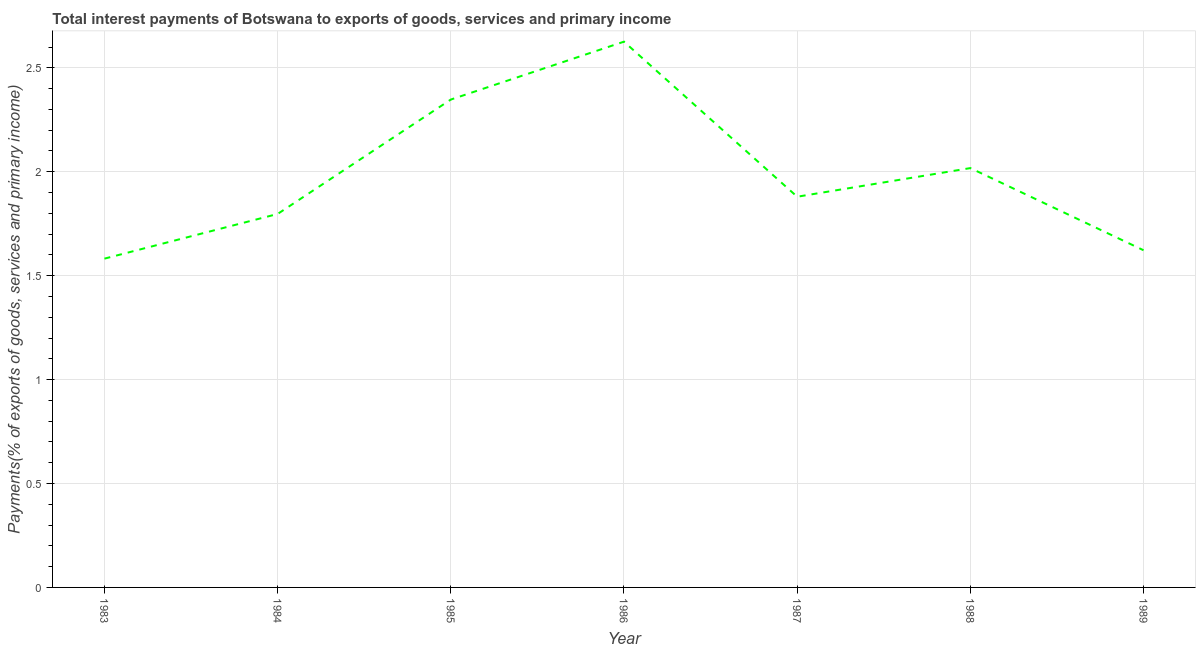What is the total interest payments on external debt in 1985?
Ensure brevity in your answer.  2.35. Across all years, what is the maximum total interest payments on external debt?
Your response must be concise. 2.63. Across all years, what is the minimum total interest payments on external debt?
Provide a short and direct response. 1.58. In which year was the total interest payments on external debt maximum?
Provide a short and direct response. 1986. In which year was the total interest payments on external debt minimum?
Give a very brief answer. 1983. What is the sum of the total interest payments on external debt?
Provide a short and direct response. 13.87. What is the difference between the total interest payments on external debt in 1985 and 1989?
Give a very brief answer. 0.73. What is the average total interest payments on external debt per year?
Offer a very short reply. 1.98. What is the median total interest payments on external debt?
Keep it short and to the point. 1.88. In how many years, is the total interest payments on external debt greater than 2 %?
Your answer should be compact. 3. What is the ratio of the total interest payments on external debt in 1987 to that in 1988?
Give a very brief answer. 0.93. What is the difference between the highest and the second highest total interest payments on external debt?
Keep it short and to the point. 0.28. Is the sum of the total interest payments on external debt in 1986 and 1988 greater than the maximum total interest payments on external debt across all years?
Offer a terse response. Yes. What is the difference between the highest and the lowest total interest payments on external debt?
Ensure brevity in your answer.  1.04. Does the total interest payments on external debt monotonically increase over the years?
Your response must be concise. No. How many lines are there?
Your answer should be very brief. 1. How many years are there in the graph?
Make the answer very short. 7. What is the difference between two consecutive major ticks on the Y-axis?
Your answer should be compact. 0.5. Does the graph contain any zero values?
Give a very brief answer. No. Does the graph contain grids?
Offer a terse response. Yes. What is the title of the graph?
Offer a terse response. Total interest payments of Botswana to exports of goods, services and primary income. What is the label or title of the X-axis?
Provide a succinct answer. Year. What is the label or title of the Y-axis?
Your answer should be compact. Payments(% of exports of goods, services and primary income). What is the Payments(% of exports of goods, services and primary income) in 1983?
Your answer should be very brief. 1.58. What is the Payments(% of exports of goods, services and primary income) of 1984?
Your answer should be compact. 1.8. What is the Payments(% of exports of goods, services and primary income) of 1985?
Ensure brevity in your answer.  2.35. What is the Payments(% of exports of goods, services and primary income) of 1986?
Keep it short and to the point. 2.63. What is the Payments(% of exports of goods, services and primary income) in 1987?
Make the answer very short. 1.88. What is the Payments(% of exports of goods, services and primary income) of 1988?
Keep it short and to the point. 2.02. What is the Payments(% of exports of goods, services and primary income) in 1989?
Ensure brevity in your answer.  1.62. What is the difference between the Payments(% of exports of goods, services and primary income) in 1983 and 1984?
Keep it short and to the point. -0.21. What is the difference between the Payments(% of exports of goods, services and primary income) in 1983 and 1985?
Ensure brevity in your answer.  -0.77. What is the difference between the Payments(% of exports of goods, services and primary income) in 1983 and 1986?
Your answer should be compact. -1.04. What is the difference between the Payments(% of exports of goods, services and primary income) in 1983 and 1987?
Ensure brevity in your answer.  -0.3. What is the difference between the Payments(% of exports of goods, services and primary income) in 1983 and 1988?
Provide a short and direct response. -0.44. What is the difference between the Payments(% of exports of goods, services and primary income) in 1983 and 1989?
Your response must be concise. -0.04. What is the difference between the Payments(% of exports of goods, services and primary income) in 1984 and 1985?
Keep it short and to the point. -0.55. What is the difference between the Payments(% of exports of goods, services and primary income) in 1984 and 1986?
Provide a succinct answer. -0.83. What is the difference between the Payments(% of exports of goods, services and primary income) in 1984 and 1987?
Your response must be concise. -0.08. What is the difference between the Payments(% of exports of goods, services and primary income) in 1984 and 1988?
Give a very brief answer. -0.22. What is the difference between the Payments(% of exports of goods, services and primary income) in 1984 and 1989?
Provide a short and direct response. 0.17. What is the difference between the Payments(% of exports of goods, services and primary income) in 1985 and 1986?
Your response must be concise. -0.28. What is the difference between the Payments(% of exports of goods, services and primary income) in 1985 and 1987?
Offer a terse response. 0.47. What is the difference between the Payments(% of exports of goods, services and primary income) in 1985 and 1988?
Your answer should be very brief. 0.33. What is the difference between the Payments(% of exports of goods, services and primary income) in 1985 and 1989?
Provide a succinct answer. 0.73. What is the difference between the Payments(% of exports of goods, services and primary income) in 1986 and 1987?
Your response must be concise. 0.75. What is the difference between the Payments(% of exports of goods, services and primary income) in 1986 and 1988?
Provide a succinct answer. 0.61. What is the difference between the Payments(% of exports of goods, services and primary income) in 1986 and 1989?
Your answer should be very brief. 1. What is the difference between the Payments(% of exports of goods, services and primary income) in 1987 and 1988?
Provide a short and direct response. -0.14. What is the difference between the Payments(% of exports of goods, services and primary income) in 1987 and 1989?
Provide a short and direct response. 0.26. What is the difference between the Payments(% of exports of goods, services and primary income) in 1988 and 1989?
Your answer should be compact. 0.4. What is the ratio of the Payments(% of exports of goods, services and primary income) in 1983 to that in 1985?
Provide a short and direct response. 0.67. What is the ratio of the Payments(% of exports of goods, services and primary income) in 1983 to that in 1986?
Offer a terse response. 0.6. What is the ratio of the Payments(% of exports of goods, services and primary income) in 1983 to that in 1987?
Your answer should be compact. 0.84. What is the ratio of the Payments(% of exports of goods, services and primary income) in 1983 to that in 1988?
Offer a terse response. 0.78. What is the ratio of the Payments(% of exports of goods, services and primary income) in 1983 to that in 1989?
Your answer should be compact. 0.97. What is the ratio of the Payments(% of exports of goods, services and primary income) in 1984 to that in 1985?
Offer a terse response. 0.77. What is the ratio of the Payments(% of exports of goods, services and primary income) in 1984 to that in 1986?
Your response must be concise. 0.68. What is the ratio of the Payments(% of exports of goods, services and primary income) in 1984 to that in 1987?
Ensure brevity in your answer.  0.96. What is the ratio of the Payments(% of exports of goods, services and primary income) in 1984 to that in 1988?
Provide a short and direct response. 0.89. What is the ratio of the Payments(% of exports of goods, services and primary income) in 1984 to that in 1989?
Keep it short and to the point. 1.11. What is the ratio of the Payments(% of exports of goods, services and primary income) in 1985 to that in 1986?
Keep it short and to the point. 0.89. What is the ratio of the Payments(% of exports of goods, services and primary income) in 1985 to that in 1987?
Your response must be concise. 1.25. What is the ratio of the Payments(% of exports of goods, services and primary income) in 1985 to that in 1988?
Keep it short and to the point. 1.16. What is the ratio of the Payments(% of exports of goods, services and primary income) in 1985 to that in 1989?
Offer a terse response. 1.45. What is the ratio of the Payments(% of exports of goods, services and primary income) in 1986 to that in 1987?
Offer a terse response. 1.4. What is the ratio of the Payments(% of exports of goods, services and primary income) in 1986 to that in 1988?
Your answer should be very brief. 1.3. What is the ratio of the Payments(% of exports of goods, services and primary income) in 1986 to that in 1989?
Your answer should be very brief. 1.62. What is the ratio of the Payments(% of exports of goods, services and primary income) in 1987 to that in 1988?
Offer a terse response. 0.93. What is the ratio of the Payments(% of exports of goods, services and primary income) in 1987 to that in 1989?
Provide a succinct answer. 1.16. What is the ratio of the Payments(% of exports of goods, services and primary income) in 1988 to that in 1989?
Offer a very short reply. 1.24. 